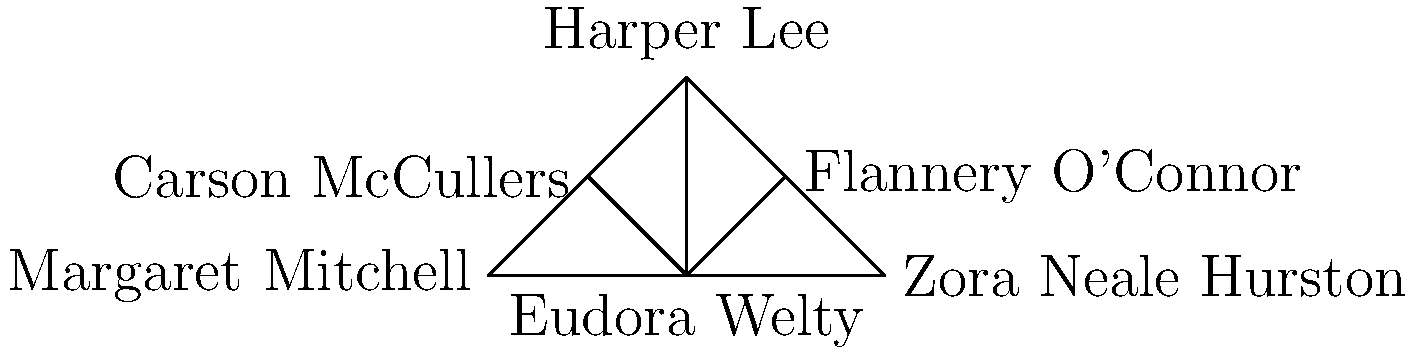In this network of influential Southern female authors, which writer has the highest degree centrality, connecting her to the most peers and potentially serving as a bridge between different literary circles? To determine the author with the highest degree centrality, we need to count the number of connections (edges) each author has in the network:

1. Eudora Welty: 5 connections (to all other authors)
2. Flannery O'Connor: 3 connections (to Welty, Lee, and Hurston)
3. Carson McCullers: 3 connections (to Welty, Lee, and Mitchell)
4. Harper Lee: 3 connections (to Welty, O'Connor, and McCullers)
5. Margaret Mitchell: 2 connections (to Welty and McCullers)
6. Zora Neale Hurston: 2 connections (to Welty and O'Connor)

Eudora Welty has the highest degree centrality with 5 connections, making her the most connected author in this network. This positions her as a central figure in Southern women's literature, potentially bridging different styles, themes, and generations of writers.
Answer: Eudora Welty 